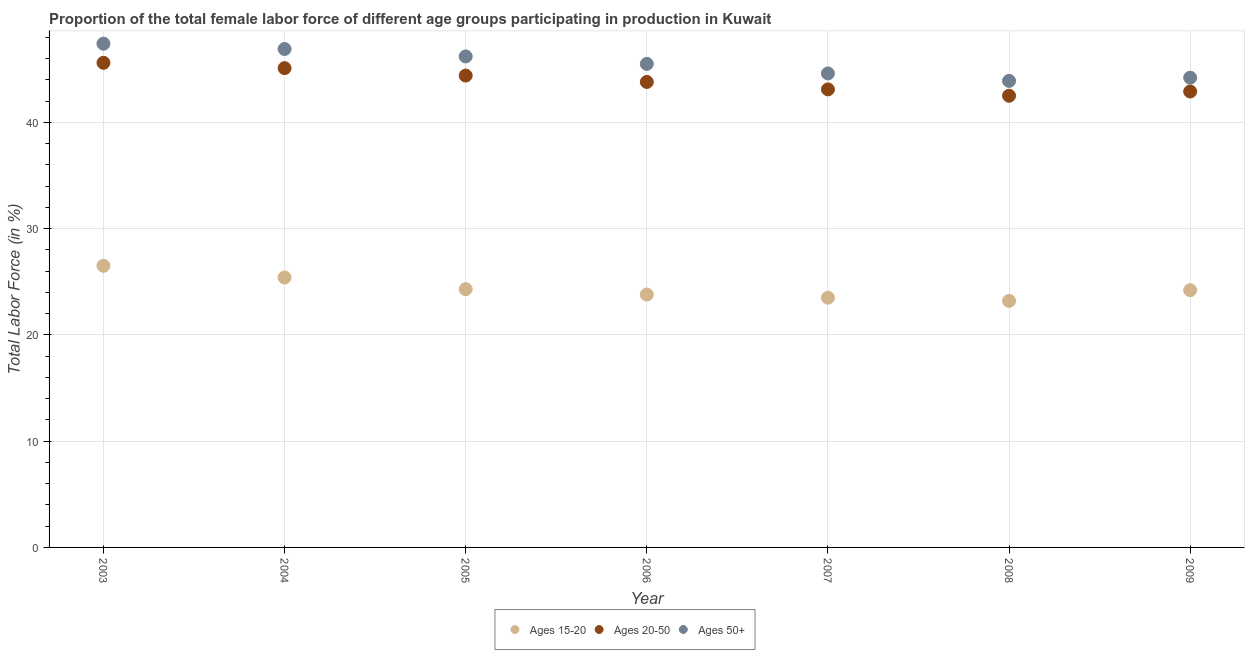How many different coloured dotlines are there?
Ensure brevity in your answer.  3. What is the percentage of female labor force above age 50 in 2009?
Your answer should be compact. 44.2. Across all years, what is the maximum percentage of female labor force within the age group 20-50?
Offer a very short reply. 45.6. Across all years, what is the minimum percentage of female labor force within the age group 15-20?
Make the answer very short. 23.2. In which year was the percentage of female labor force above age 50 maximum?
Your answer should be compact. 2003. What is the total percentage of female labor force within the age group 15-20 in the graph?
Ensure brevity in your answer.  170.9. What is the difference between the percentage of female labor force above age 50 in 2006 and that in 2008?
Your answer should be compact. 1.6. What is the difference between the percentage of female labor force within the age group 15-20 in 2007 and the percentage of female labor force within the age group 20-50 in 2009?
Make the answer very short. -19.4. What is the average percentage of female labor force within the age group 15-20 per year?
Give a very brief answer. 24.41. In the year 2009, what is the difference between the percentage of female labor force within the age group 15-20 and percentage of female labor force within the age group 20-50?
Your answer should be compact. -18.7. What is the ratio of the percentage of female labor force within the age group 15-20 in 2006 to that in 2009?
Your answer should be very brief. 0.98. What is the difference between the highest and the second highest percentage of female labor force within the age group 15-20?
Your answer should be very brief. 1.1. What is the difference between the highest and the lowest percentage of female labor force above age 50?
Your response must be concise. 3.5. In how many years, is the percentage of female labor force within the age group 15-20 greater than the average percentage of female labor force within the age group 15-20 taken over all years?
Provide a succinct answer. 2. Is it the case that in every year, the sum of the percentage of female labor force within the age group 15-20 and percentage of female labor force within the age group 20-50 is greater than the percentage of female labor force above age 50?
Ensure brevity in your answer.  Yes. Does the percentage of female labor force within the age group 15-20 monotonically increase over the years?
Offer a terse response. No. Is the percentage of female labor force above age 50 strictly greater than the percentage of female labor force within the age group 20-50 over the years?
Give a very brief answer. Yes. Is the percentage of female labor force within the age group 15-20 strictly less than the percentage of female labor force above age 50 over the years?
Your answer should be compact. Yes. How many years are there in the graph?
Provide a succinct answer. 7. What is the difference between two consecutive major ticks on the Y-axis?
Your answer should be compact. 10. Where does the legend appear in the graph?
Offer a very short reply. Bottom center. How are the legend labels stacked?
Make the answer very short. Horizontal. What is the title of the graph?
Make the answer very short. Proportion of the total female labor force of different age groups participating in production in Kuwait. What is the Total Labor Force (in %) in Ages 20-50 in 2003?
Your answer should be very brief. 45.6. What is the Total Labor Force (in %) of Ages 50+ in 2003?
Your answer should be compact. 47.4. What is the Total Labor Force (in %) of Ages 15-20 in 2004?
Your answer should be very brief. 25.4. What is the Total Labor Force (in %) in Ages 20-50 in 2004?
Provide a short and direct response. 45.1. What is the Total Labor Force (in %) of Ages 50+ in 2004?
Offer a very short reply. 46.9. What is the Total Labor Force (in %) in Ages 15-20 in 2005?
Offer a terse response. 24.3. What is the Total Labor Force (in %) in Ages 20-50 in 2005?
Provide a short and direct response. 44.4. What is the Total Labor Force (in %) of Ages 50+ in 2005?
Offer a terse response. 46.2. What is the Total Labor Force (in %) in Ages 15-20 in 2006?
Ensure brevity in your answer.  23.8. What is the Total Labor Force (in %) in Ages 20-50 in 2006?
Give a very brief answer. 43.8. What is the Total Labor Force (in %) of Ages 50+ in 2006?
Give a very brief answer. 45.5. What is the Total Labor Force (in %) of Ages 15-20 in 2007?
Keep it short and to the point. 23.5. What is the Total Labor Force (in %) of Ages 20-50 in 2007?
Your response must be concise. 43.1. What is the Total Labor Force (in %) of Ages 50+ in 2007?
Provide a succinct answer. 44.6. What is the Total Labor Force (in %) of Ages 15-20 in 2008?
Offer a terse response. 23.2. What is the Total Labor Force (in %) of Ages 20-50 in 2008?
Ensure brevity in your answer.  42.5. What is the Total Labor Force (in %) in Ages 50+ in 2008?
Make the answer very short. 43.9. What is the Total Labor Force (in %) in Ages 15-20 in 2009?
Your answer should be very brief. 24.2. What is the Total Labor Force (in %) in Ages 20-50 in 2009?
Offer a very short reply. 42.9. What is the Total Labor Force (in %) in Ages 50+ in 2009?
Make the answer very short. 44.2. Across all years, what is the maximum Total Labor Force (in %) of Ages 15-20?
Make the answer very short. 26.5. Across all years, what is the maximum Total Labor Force (in %) of Ages 20-50?
Your answer should be very brief. 45.6. Across all years, what is the maximum Total Labor Force (in %) in Ages 50+?
Keep it short and to the point. 47.4. Across all years, what is the minimum Total Labor Force (in %) of Ages 15-20?
Provide a short and direct response. 23.2. Across all years, what is the minimum Total Labor Force (in %) of Ages 20-50?
Your response must be concise. 42.5. Across all years, what is the minimum Total Labor Force (in %) in Ages 50+?
Provide a short and direct response. 43.9. What is the total Total Labor Force (in %) of Ages 15-20 in the graph?
Keep it short and to the point. 170.9. What is the total Total Labor Force (in %) in Ages 20-50 in the graph?
Make the answer very short. 307.4. What is the total Total Labor Force (in %) in Ages 50+ in the graph?
Offer a terse response. 318.7. What is the difference between the Total Labor Force (in %) in Ages 15-20 in 2003 and that in 2004?
Your answer should be compact. 1.1. What is the difference between the Total Labor Force (in %) in Ages 20-50 in 2003 and that in 2004?
Offer a terse response. 0.5. What is the difference between the Total Labor Force (in %) of Ages 50+ in 2003 and that in 2004?
Offer a very short reply. 0.5. What is the difference between the Total Labor Force (in %) of Ages 15-20 in 2003 and that in 2005?
Your answer should be compact. 2.2. What is the difference between the Total Labor Force (in %) in Ages 20-50 in 2003 and that in 2005?
Your answer should be very brief. 1.2. What is the difference between the Total Labor Force (in %) of Ages 20-50 in 2003 and that in 2006?
Offer a terse response. 1.8. What is the difference between the Total Labor Force (in %) in Ages 50+ in 2003 and that in 2006?
Make the answer very short. 1.9. What is the difference between the Total Labor Force (in %) in Ages 15-20 in 2003 and that in 2007?
Provide a short and direct response. 3. What is the difference between the Total Labor Force (in %) of Ages 20-50 in 2003 and that in 2007?
Your response must be concise. 2.5. What is the difference between the Total Labor Force (in %) in Ages 50+ in 2003 and that in 2007?
Ensure brevity in your answer.  2.8. What is the difference between the Total Labor Force (in %) of Ages 15-20 in 2003 and that in 2008?
Provide a short and direct response. 3.3. What is the difference between the Total Labor Force (in %) of Ages 20-50 in 2003 and that in 2008?
Your response must be concise. 3.1. What is the difference between the Total Labor Force (in %) of Ages 50+ in 2003 and that in 2008?
Keep it short and to the point. 3.5. What is the difference between the Total Labor Force (in %) of Ages 15-20 in 2003 and that in 2009?
Ensure brevity in your answer.  2.3. What is the difference between the Total Labor Force (in %) in Ages 20-50 in 2003 and that in 2009?
Your answer should be compact. 2.7. What is the difference between the Total Labor Force (in %) of Ages 15-20 in 2004 and that in 2007?
Your response must be concise. 1.9. What is the difference between the Total Labor Force (in %) of Ages 20-50 in 2004 and that in 2007?
Your answer should be very brief. 2. What is the difference between the Total Labor Force (in %) in Ages 50+ in 2004 and that in 2007?
Your response must be concise. 2.3. What is the difference between the Total Labor Force (in %) of Ages 20-50 in 2004 and that in 2008?
Provide a short and direct response. 2.6. What is the difference between the Total Labor Force (in %) of Ages 50+ in 2004 and that in 2008?
Keep it short and to the point. 3. What is the difference between the Total Labor Force (in %) of Ages 20-50 in 2004 and that in 2009?
Make the answer very short. 2.2. What is the difference between the Total Labor Force (in %) in Ages 50+ in 2004 and that in 2009?
Provide a short and direct response. 2.7. What is the difference between the Total Labor Force (in %) in Ages 15-20 in 2005 and that in 2006?
Offer a very short reply. 0.5. What is the difference between the Total Labor Force (in %) of Ages 20-50 in 2005 and that in 2006?
Your response must be concise. 0.6. What is the difference between the Total Labor Force (in %) of Ages 50+ in 2005 and that in 2006?
Provide a short and direct response. 0.7. What is the difference between the Total Labor Force (in %) in Ages 20-50 in 2005 and that in 2007?
Ensure brevity in your answer.  1.3. What is the difference between the Total Labor Force (in %) of Ages 50+ in 2005 and that in 2007?
Provide a short and direct response. 1.6. What is the difference between the Total Labor Force (in %) in Ages 15-20 in 2005 and that in 2008?
Make the answer very short. 1.1. What is the difference between the Total Labor Force (in %) in Ages 20-50 in 2005 and that in 2008?
Ensure brevity in your answer.  1.9. What is the difference between the Total Labor Force (in %) in Ages 15-20 in 2005 and that in 2009?
Offer a terse response. 0.1. What is the difference between the Total Labor Force (in %) in Ages 50+ in 2006 and that in 2008?
Your answer should be very brief. 1.6. What is the difference between the Total Labor Force (in %) in Ages 20-50 in 2006 and that in 2009?
Provide a short and direct response. 0.9. What is the difference between the Total Labor Force (in %) in Ages 50+ in 2006 and that in 2009?
Your answer should be very brief. 1.3. What is the difference between the Total Labor Force (in %) in Ages 20-50 in 2007 and that in 2008?
Ensure brevity in your answer.  0.6. What is the difference between the Total Labor Force (in %) of Ages 50+ in 2007 and that in 2009?
Ensure brevity in your answer.  0.4. What is the difference between the Total Labor Force (in %) of Ages 15-20 in 2008 and that in 2009?
Your response must be concise. -1. What is the difference between the Total Labor Force (in %) of Ages 20-50 in 2008 and that in 2009?
Your response must be concise. -0.4. What is the difference between the Total Labor Force (in %) in Ages 50+ in 2008 and that in 2009?
Provide a short and direct response. -0.3. What is the difference between the Total Labor Force (in %) in Ages 15-20 in 2003 and the Total Labor Force (in %) in Ages 20-50 in 2004?
Keep it short and to the point. -18.6. What is the difference between the Total Labor Force (in %) in Ages 15-20 in 2003 and the Total Labor Force (in %) in Ages 50+ in 2004?
Give a very brief answer. -20.4. What is the difference between the Total Labor Force (in %) in Ages 15-20 in 2003 and the Total Labor Force (in %) in Ages 20-50 in 2005?
Offer a very short reply. -17.9. What is the difference between the Total Labor Force (in %) in Ages 15-20 in 2003 and the Total Labor Force (in %) in Ages 50+ in 2005?
Give a very brief answer. -19.7. What is the difference between the Total Labor Force (in %) of Ages 15-20 in 2003 and the Total Labor Force (in %) of Ages 20-50 in 2006?
Your answer should be very brief. -17.3. What is the difference between the Total Labor Force (in %) of Ages 15-20 in 2003 and the Total Labor Force (in %) of Ages 50+ in 2006?
Your response must be concise. -19. What is the difference between the Total Labor Force (in %) of Ages 15-20 in 2003 and the Total Labor Force (in %) of Ages 20-50 in 2007?
Ensure brevity in your answer.  -16.6. What is the difference between the Total Labor Force (in %) in Ages 15-20 in 2003 and the Total Labor Force (in %) in Ages 50+ in 2007?
Provide a succinct answer. -18.1. What is the difference between the Total Labor Force (in %) of Ages 15-20 in 2003 and the Total Labor Force (in %) of Ages 50+ in 2008?
Provide a succinct answer. -17.4. What is the difference between the Total Labor Force (in %) of Ages 20-50 in 2003 and the Total Labor Force (in %) of Ages 50+ in 2008?
Give a very brief answer. 1.7. What is the difference between the Total Labor Force (in %) of Ages 15-20 in 2003 and the Total Labor Force (in %) of Ages 20-50 in 2009?
Your response must be concise. -16.4. What is the difference between the Total Labor Force (in %) in Ages 15-20 in 2003 and the Total Labor Force (in %) in Ages 50+ in 2009?
Offer a terse response. -17.7. What is the difference between the Total Labor Force (in %) of Ages 15-20 in 2004 and the Total Labor Force (in %) of Ages 50+ in 2005?
Give a very brief answer. -20.8. What is the difference between the Total Labor Force (in %) in Ages 15-20 in 2004 and the Total Labor Force (in %) in Ages 20-50 in 2006?
Provide a succinct answer. -18.4. What is the difference between the Total Labor Force (in %) of Ages 15-20 in 2004 and the Total Labor Force (in %) of Ages 50+ in 2006?
Offer a very short reply. -20.1. What is the difference between the Total Labor Force (in %) in Ages 15-20 in 2004 and the Total Labor Force (in %) in Ages 20-50 in 2007?
Your answer should be compact. -17.7. What is the difference between the Total Labor Force (in %) in Ages 15-20 in 2004 and the Total Labor Force (in %) in Ages 50+ in 2007?
Your answer should be very brief. -19.2. What is the difference between the Total Labor Force (in %) in Ages 15-20 in 2004 and the Total Labor Force (in %) in Ages 20-50 in 2008?
Your response must be concise. -17.1. What is the difference between the Total Labor Force (in %) of Ages 15-20 in 2004 and the Total Labor Force (in %) of Ages 50+ in 2008?
Offer a very short reply. -18.5. What is the difference between the Total Labor Force (in %) in Ages 15-20 in 2004 and the Total Labor Force (in %) in Ages 20-50 in 2009?
Your response must be concise. -17.5. What is the difference between the Total Labor Force (in %) of Ages 15-20 in 2004 and the Total Labor Force (in %) of Ages 50+ in 2009?
Your answer should be very brief. -18.8. What is the difference between the Total Labor Force (in %) in Ages 20-50 in 2004 and the Total Labor Force (in %) in Ages 50+ in 2009?
Your response must be concise. 0.9. What is the difference between the Total Labor Force (in %) in Ages 15-20 in 2005 and the Total Labor Force (in %) in Ages 20-50 in 2006?
Offer a terse response. -19.5. What is the difference between the Total Labor Force (in %) of Ages 15-20 in 2005 and the Total Labor Force (in %) of Ages 50+ in 2006?
Provide a short and direct response. -21.2. What is the difference between the Total Labor Force (in %) in Ages 15-20 in 2005 and the Total Labor Force (in %) in Ages 20-50 in 2007?
Offer a very short reply. -18.8. What is the difference between the Total Labor Force (in %) in Ages 15-20 in 2005 and the Total Labor Force (in %) in Ages 50+ in 2007?
Provide a short and direct response. -20.3. What is the difference between the Total Labor Force (in %) in Ages 20-50 in 2005 and the Total Labor Force (in %) in Ages 50+ in 2007?
Provide a short and direct response. -0.2. What is the difference between the Total Labor Force (in %) of Ages 15-20 in 2005 and the Total Labor Force (in %) of Ages 20-50 in 2008?
Keep it short and to the point. -18.2. What is the difference between the Total Labor Force (in %) in Ages 15-20 in 2005 and the Total Labor Force (in %) in Ages 50+ in 2008?
Provide a short and direct response. -19.6. What is the difference between the Total Labor Force (in %) in Ages 20-50 in 2005 and the Total Labor Force (in %) in Ages 50+ in 2008?
Provide a short and direct response. 0.5. What is the difference between the Total Labor Force (in %) in Ages 15-20 in 2005 and the Total Labor Force (in %) in Ages 20-50 in 2009?
Provide a succinct answer. -18.6. What is the difference between the Total Labor Force (in %) of Ages 15-20 in 2005 and the Total Labor Force (in %) of Ages 50+ in 2009?
Give a very brief answer. -19.9. What is the difference between the Total Labor Force (in %) in Ages 20-50 in 2005 and the Total Labor Force (in %) in Ages 50+ in 2009?
Offer a terse response. 0.2. What is the difference between the Total Labor Force (in %) in Ages 15-20 in 2006 and the Total Labor Force (in %) in Ages 20-50 in 2007?
Provide a short and direct response. -19.3. What is the difference between the Total Labor Force (in %) of Ages 15-20 in 2006 and the Total Labor Force (in %) of Ages 50+ in 2007?
Provide a succinct answer. -20.8. What is the difference between the Total Labor Force (in %) of Ages 20-50 in 2006 and the Total Labor Force (in %) of Ages 50+ in 2007?
Your answer should be compact. -0.8. What is the difference between the Total Labor Force (in %) of Ages 15-20 in 2006 and the Total Labor Force (in %) of Ages 20-50 in 2008?
Make the answer very short. -18.7. What is the difference between the Total Labor Force (in %) of Ages 15-20 in 2006 and the Total Labor Force (in %) of Ages 50+ in 2008?
Keep it short and to the point. -20.1. What is the difference between the Total Labor Force (in %) in Ages 15-20 in 2006 and the Total Labor Force (in %) in Ages 20-50 in 2009?
Your response must be concise. -19.1. What is the difference between the Total Labor Force (in %) in Ages 15-20 in 2006 and the Total Labor Force (in %) in Ages 50+ in 2009?
Make the answer very short. -20.4. What is the difference between the Total Labor Force (in %) in Ages 20-50 in 2006 and the Total Labor Force (in %) in Ages 50+ in 2009?
Your answer should be compact. -0.4. What is the difference between the Total Labor Force (in %) of Ages 15-20 in 2007 and the Total Labor Force (in %) of Ages 50+ in 2008?
Your answer should be compact. -20.4. What is the difference between the Total Labor Force (in %) in Ages 15-20 in 2007 and the Total Labor Force (in %) in Ages 20-50 in 2009?
Your response must be concise. -19.4. What is the difference between the Total Labor Force (in %) of Ages 15-20 in 2007 and the Total Labor Force (in %) of Ages 50+ in 2009?
Make the answer very short. -20.7. What is the difference between the Total Labor Force (in %) of Ages 15-20 in 2008 and the Total Labor Force (in %) of Ages 20-50 in 2009?
Offer a terse response. -19.7. What is the difference between the Total Labor Force (in %) of Ages 15-20 in 2008 and the Total Labor Force (in %) of Ages 50+ in 2009?
Give a very brief answer. -21. What is the difference between the Total Labor Force (in %) in Ages 20-50 in 2008 and the Total Labor Force (in %) in Ages 50+ in 2009?
Make the answer very short. -1.7. What is the average Total Labor Force (in %) in Ages 15-20 per year?
Give a very brief answer. 24.41. What is the average Total Labor Force (in %) of Ages 20-50 per year?
Your answer should be compact. 43.91. What is the average Total Labor Force (in %) in Ages 50+ per year?
Offer a terse response. 45.53. In the year 2003, what is the difference between the Total Labor Force (in %) in Ages 15-20 and Total Labor Force (in %) in Ages 20-50?
Your response must be concise. -19.1. In the year 2003, what is the difference between the Total Labor Force (in %) in Ages 15-20 and Total Labor Force (in %) in Ages 50+?
Provide a succinct answer. -20.9. In the year 2003, what is the difference between the Total Labor Force (in %) of Ages 20-50 and Total Labor Force (in %) of Ages 50+?
Ensure brevity in your answer.  -1.8. In the year 2004, what is the difference between the Total Labor Force (in %) of Ages 15-20 and Total Labor Force (in %) of Ages 20-50?
Provide a short and direct response. -19.7. In the year 2004, what is the difference between the Total Labor Force (in %) in Ages 15-20 and Total Labor Force (in %) in Ages 50+?
Offer a very short reply. -21.5. In the year 2005, what is the difference between the Total Labor Force (in %) of Ages 15-20 and Total Labor Force (in %) of Ages 20-50?
Provide a succinct answer. -20.1. In the year 2005, what is the difference between the Total Labor Force (in %) in Ages 15-20 and Total Labor Force (in %) in Ages 50+?
Your response must be concise. -21.9. In the year 2005, what is the difference between the Total Labor Force (in %) of Ages 20-50 and Total Labor Force (in %) of Ages 50+?
Keep it short and to the point. -1.8. In the year 2006, what is the difference between the Total Labor Force (in %) of Ages 15-20 and Total Labor Force (in %) of Ages 50+?
Your answer should be compact. -21.7. In the year 2006, what is the difference between the Total Labor Force (in %) in Ages 20-50 and Total Labor Force (in %) in Ages 50+?
Give a very brief answer. -1.7. In the year 2007, what is the difference between the Total Labor Force (in %) in Ages 15-20 and Total Labor Force (in %) in Ages 20-50?
Your response must be concise. -19.6. In the year 2007, what is the difference between the Total Labor Force (in %) in Ages 15-20 and Total Labor Force (in %) in Ages 50+?
Your answer should be very brief. -21.1. In the year 2008, what is the difference between the Total Labor Force (in %) of Ages 15-20 and Total Labor Force (in %) of Ages 20-50?
Offer a very short reply. -19.3. In the year 2008, what is the difference between the Total Labor Force (in %) of Ages 15-20 and Total Labor Force (in %) of Ages 50+?
Give a very brief answer. -20.7. In the year 2009, what is the difference between the Total Labor Force (in %) of Ages 15-20 and Total Labor Force (in %) of Ages 20-50?
Offer a very short reply. -18.7. In the year 2009, what is the difference between the Total Labor Force (in %) in Ages 20-50 and Total Labor Force (in %) in Ages 50+?
Ensure brevity in your answer.  -1.3. What is the ratio of the Total Labor Force (in %) of Ages 15-20 in 2003 to that in 2004?
Your response must be concise. 1.04. What is the ratio of the Total Labor Force (in %) in Ages 20-50 in 2003 to that in 2004?
Offer a very short reply. 1.01. What is the ratio of the Total Labor Force (in %) in Ages 50+ in 2003 to that in 2004?
Your response must be concise. 1.01. What is the ratio of the Total Labor Force (in %) of Ages 15-20 in 2003 to that in 2005?
Your answer should be compact. 1.09. What is the ratio of the Total Labor Force (in %) of Ages 20-50 in 2003 to that in 2005?
Ensure brevity in your answer.  1.03. What is the ratio of the Total Labor Force (in %) in Ages 50+ in 2003 to that in 2005?
Provide a succinct answer. 1.03. What is the ratio of the Total Labor Force (in %) of Ages 15-20 in 2003 to that in 2006?
Make the answer very short. 1.11. What is the ratio of the Total Labor Force (in %) in Ages 20-50 in 2003 to that in 2006?
Offer a very short reply. 1.04. What is the ratio of the Total Labor Force (in %) in Ages 50+ in 2003 to that in 2006?
Provide a short and direct response. 1.04. What is the ratio of the Total Labor Force (in %) in Ages 15-20 in 2003 to that in 2007?
Ensure brevity in your answer.  1.13. What is the ratio of the Total Labor Force (in %) of Ages 20-50 in 2003 to that in 2007?
Your response must be concise. 1.06. What is the ratio of the Total Labor Force (in %) of Ages 50+ in 2003 to that in 2007?
Make the answer very short. 1.06. What is the ratio of the Total Labor Force (in %) of Ages 15-20 in 2003 to that in 2008?
Your response must be concise. 1.14. What is the ratio of the Total Labor Force (in %) in Ages 20-50 in 2003 to that in 2008?
Make the answer very short. 1.07. What is the ratio of the Total Labor Force (in %) of Ages 50+ in 2003 to that in 2008?
Your response must be concise. 1.08. What is the ratio of the Total Labor Force (in %) of Ages 15-20 in 2003 to that in 2009?
Offer a terse response. 1.09. What is the ratio of the Total Labor Force (in %) of Ages 20-50 in 2003 to that in 2009?
Provide a succinct answer. 1.06. What is the ratio of the Total Labor Force (in %) of Ages 50+ in 2003 to that in 2009?
Ensure brevity in your answer.  1.07. What is the ratio of the Total Labor Force (in %) of Ages 15-20 in 2004 to that in 2005?
Your answer should be very brief. 1.05. What is the ratio of the Total Labor Force (in %) in Ages 20-50 in 2004 to that in 2005?
Make the answer very short. 1.02. What is the ratio of the Total Labor Force (in %) of Ages 50+ in 2004 to that in 2005?
Ensure brevity in your answer.  1.02. What is the ratio of the Total Labor Force (in %) of Ages 15-20 in 2004 to that in 2006?
Keep it short and to the point. 1.07. What is the ratio of the Total Labor Force (in %) of Ages 20-50 in 2004 to that in 2006?
Ensure brevity in your answer.  1.03. What is the ratio of the Total Labor Force (in %) in Ages 50+ in 2004 to that in 2006?
Your response must be concise. 1.03. What is the ratio of the Total Labor Force (in %) of Ages 15-20 in 2004 to that in 2007?
Give a very brief answer. 1.08. What is the ratio of the Total Labor Force (in %) in Ages 20-50 in 2004 to that in 2007?
Your response must be concise. 1.05. What is the ratio of the Total Labor Force (in %) in Ages 50+ in 2004 to that in 2007?
Provide a short and direct response. 1.05. What is the ratio of the Total Labor Force (in %) of Ages 15-20 in 2004 to that in 2008?
Provide a succinct answer. 1.09. What is the ratio of the Total Labor Force (in %) in Ages 20-50 in 2004 to that in 2008?
Make the answer very short. 1.06. What is the ratio of the Total Labor Force (in %) of Ages 50+ in 2004 to that in 2008?
Offer a very short reply. 1.07. What is the ratio of the Total Labor Force (in %) of Ages 15-20 in 2004 to that in 2009?
Offer a terse response. 1.05. What is the ratio of the Total Labor Force (in %) in Ages 20-50 in 2004 to that in 2009?
Give a very brief answer. 1.05. What is the ratio of the Total Labor Force (in %) in Ages 50+ in 2004 to that in 2009?
Your answer should be compact. 1.06. What is the ratio of the Total Labor Force (in %) of Ages 15-20 in 2005 to that in 2006?
Your answer should be very brief. 1.02. What is the ratio of the Total Labor Force (in %) in Ages 20-50 in 2005 to that in 2006?
Offer a very short reply. 1.01. What is the ratio of the Total Labor Force (in %) of Ages 50+ in 2005 to that in 2006?
Your answer should be very brief. 1.02. What is the ratio of the Total Labor Force (in %) of Ages 15-20 in 2005 to that in 2007?
Your answer should be very brief. 1.03. What is the ratio of the Total Labor Force (in %) of Ages 20-50 in 2005 to that in 2007?
Provide a short and direct response. 1.03. What is the ratio of the Total Labor Force (in %) in Ages 50+ in 2005 to that in 2007?
Ensure brevity in your answer.  1.04. What is the ratio of the Total Labor Force (in %) of Ages 15-20 in 2005 to that in 2008?
Give a very brief answer. 1.05. What is the ratio of the Total Labor Force (in %) in Ages 20-50 in 2005 to that in 2008?
Offer a terse response. 1.04. What is the ratio of the Total Labor Force (in %) of Ages 50+ in 2005 to that in 2008?
Your answer should be compact. 1.05. What is the ratio of the Total Labor Force (in %) in Ages 15-20 in 2005 to that in 2009?
Provide a short and direct response. 1. What is the ratio of the Total Labor Force (in %) in Ages 20-50 in 2005 to that in 2009?
Provide a short and direct response. 1.03. What is the ratio of the Total Labor Force (in %) in Ages 50+ in 2005 to that in 2009?
Keep it short and to the point. 1.05. What is the ratio of the Total Labor Force (in %) of Ages 15-20 in 2006 to that in 2007?
Provide a short and direct response. 1.01. What is the ratio of the Total Labor Force (in %) of Ages 20-50 in 2006 to that in 2007?
Provide a short and direct response. 1.02. What is the ratio of the Total Labor Force (in %) in Ages 50+ in 2006 to that in 2007?
Provide a short and direct response. 1.02. What is the ratio of the Total Labor Force (in %) in Ages 15-20 in 2006 to that in 2008?
Keep it short and to the point. 1.03. What is the ratio of the Total Labor Force (in %) of Ages 20-50 in 2006 to that in 2008?
Your answer should be very brief. 1.03. What is the ratio of the Total Labor Force (in %) of Ages 50+ in 2006 to that in 2008?
Give a very brief answer. 1.04. What is the ratio of the Total Labor Force (in %) in Ages 15-20 in 2006 to that in 2009?
Keep it short and to the point. 0.98. What is the ratio of the Total Labor Force (in %) in Ages 50+ in 2006 to that in 2009?
Ensure brevity in your answer.  1.03. What is the ratio of the Total Labor Force (in %) of Ages 15-20 in 2007 to that in 2008?
Keep it short and to the point. 1.01. What is the ratio of the Total Labor Force (in %) in Ages 20-50 in 2007 to that in 2008?
Your response must be concise. 1.01. What is the ratio of the Total Labor Force (in %) of Ages 50+ in 2007 to that in 2008?
Your response must be concise. 1.02. What is the ratio of the Total Labor Force (in %) in Ages 15-20 in 2007 to that in 2009?
Your response must be concise. 0.97. What is the ratio of the Total Labor Force (in %) in Ages 20-50 in 2007 to that in 2009?
Provide a short and direct response. 1. What is the ratio of the Total Labor Force (in %) of Ages 50+ in 2007 to that in 2009?
Offer a terse response. 1.01. What is the ratio of the Total Labor Force (in %) of Ages 15-20 in 2008 to that in 2009?
Give a very brief answer. 0.96. What is the ratio of the Total Labor Force (in %) of Ages 20-50 in 2008 to that in 2009?
Give a very brief answer. 0.99. What is the ratio of the Total Labor Force (in %) in Ages 50+ in 2008 to that in 2009?
Offer a terse response. 0.99. What is the difference between the highest and the lowest Total Labor Force (in %) of Ages 15-20?
Give a very brief answer. 3.3. 